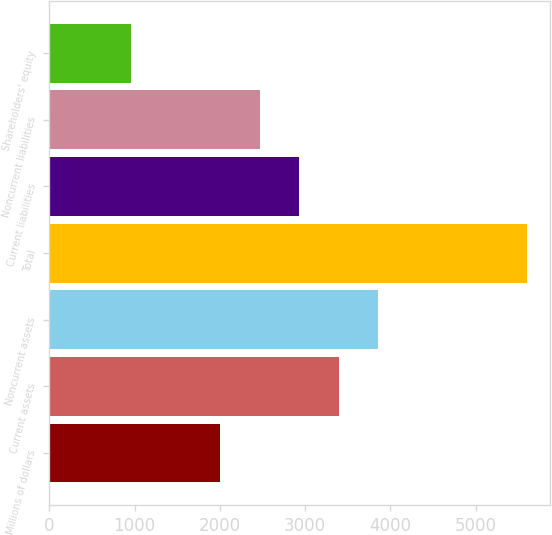Convert chart. <chart><loc_0><loc_0><loc_500><loc_500><bar_chart><fcel>Millions of dollars<fcel>Current assets<fcel>Noncurrent assets<fcel>Total<fcel>Current liabilities<fcel>Noncurrent liabilities<fcel>Shareholders' equity<nl><fcel>2003<fcel>3395.3<fcel>3859.4<fcel>5596<fcel>2931.2<fcel>2467.1<fcel>955<nl></chart> 